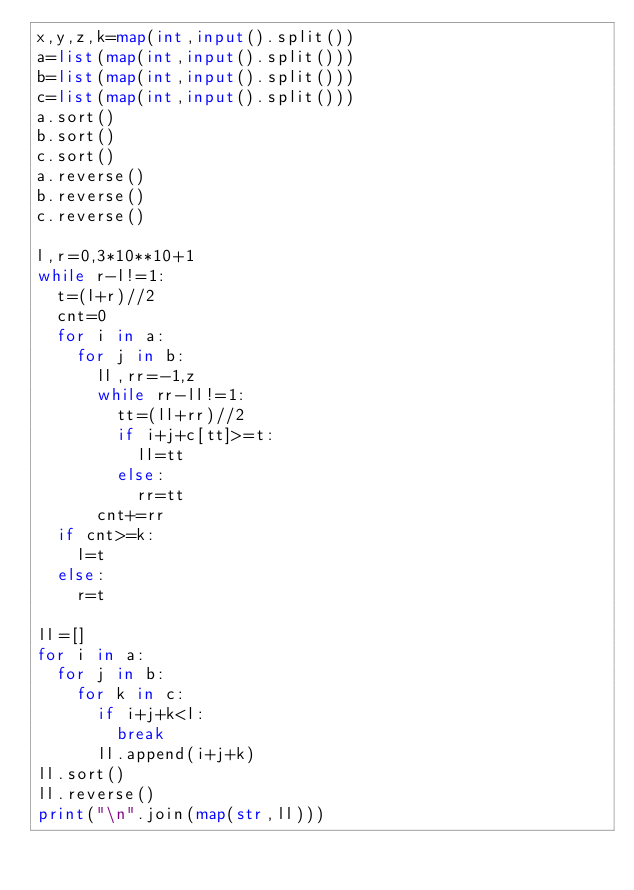<code> <loc_0><loc_0><loc_500><loc_500><_Python_>x,y,z,k=map(int,input().split())
a=list(map(int,input().split()))
b=list(map(int,input().split()))
c=list(map(int,input().split()))
a.sort()
b.sort()
c.sort()
a.reverse()
b.reverse()
c.reverse()

l,r=0,3*10**10+1
while r-l!=1:
  t=(l+r)//2
  cnt=0
  for i in a:
    for j in b:
      ll,rr=-1,z
      while rr-ll!=1:
        tt=(ll+rr)//2
        if i+j+c[tt]>=t:
          ll=tt
        else:
          rr=tt
      cnt+=rr
  if cnt>=k:
    l=t
  else:
    r=t

ll=[]
for i in a:
  for j in b:
    for k in c:
      if i+j+k<l:
        break
      ll.append(i+j+k)
ll.sort()
ll.reverse()
print("\n".join(map(str,ll)))</code> 